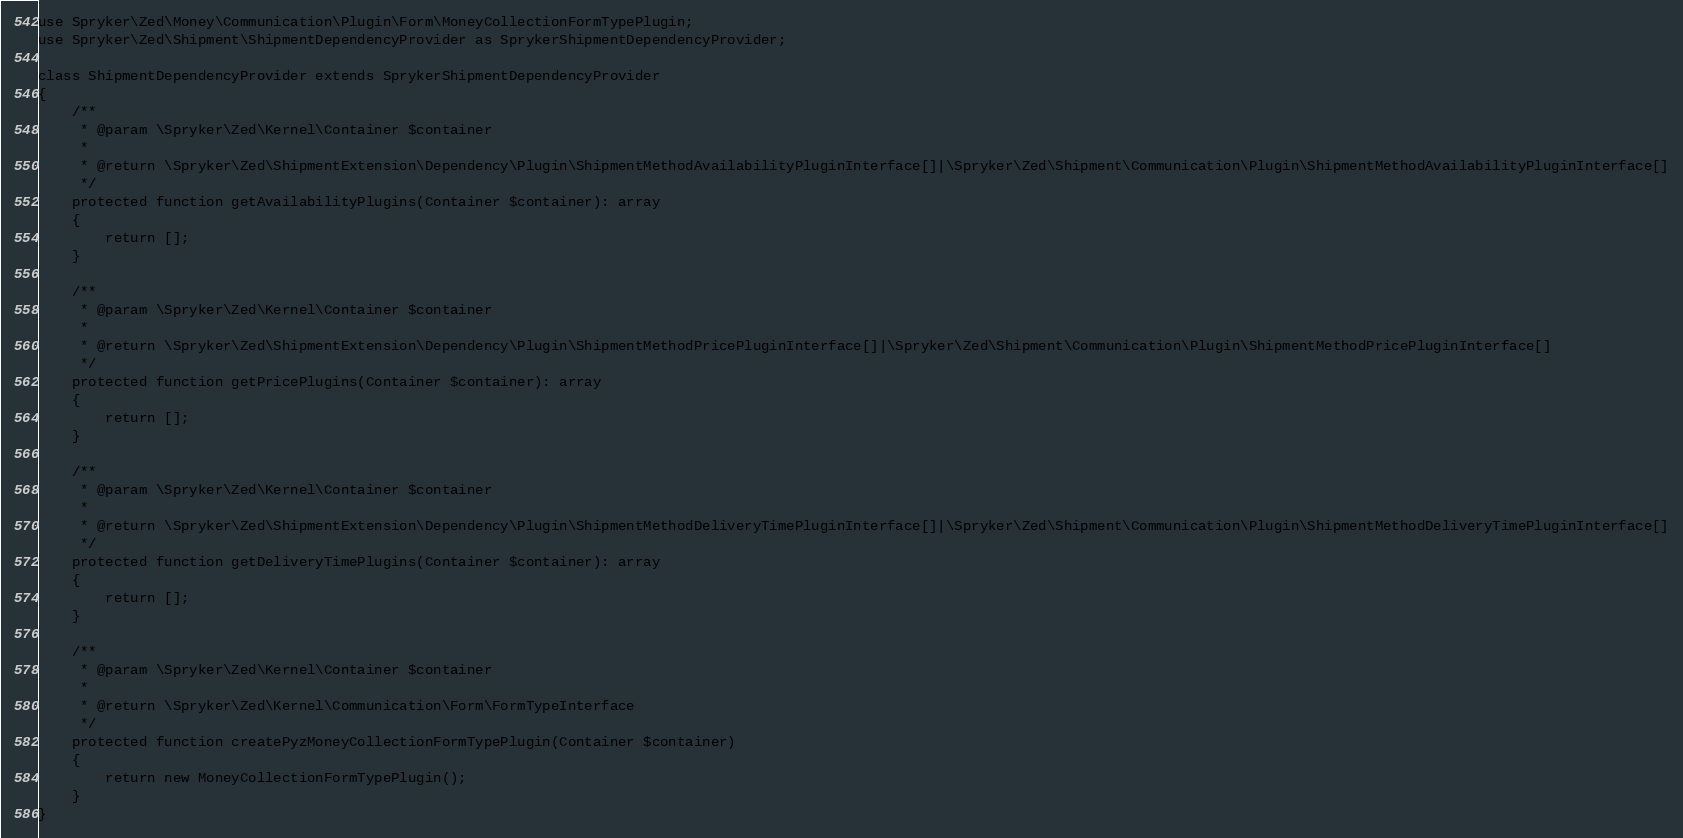Convert code to text. <code><loc_0><loc_0><loc_500><loc_500><_PHP_>use Spryker\Zed\Money\Communication\Plugin\Form\MoneyCollectionFormTypePlugin;
use Spryker\Zed\Shipment\ShipmentDependencyProvider as SprykerShipmentDependencyProvider;

class ShipmentDependencyProvider extends SprykerShipmentDependencyProvider
{
    /**
     * @param \Spryker\Zed\Kernel\Container $container
     *
     * @return \Spryker\Zed\ShipmentExtension\Dependency\Plugin\ShipmentMethodAvailabilityPluginInterface[]|\Spryker\Zed\Shipment\Communication\Plugin\ShipmentMethodAvailabilityPluginInterface[]
     */
    protected function getAvailabilityPlugins(Container $container): array
    {
        return [];
    }

    /**
     * @param \Spryker\Zed\Kernel\Container $container
     *
     * @return \Spryker\Zed\ShipmentExtension\Dependency\Plugin\ShipmentMethodPricePluginInterface[]|\Spryker\Zed\Shipment\Communication\Plugin\ShipmentMethodPricePluginInterface[]
     */
    protected function getPricePlugins(Container $container): array
    {
        return [];
    }

    /**
     * @param \Spryker\Zed\Kernel\Container $container
     *
     * @return \Spryker\Zed\ShipmentExtension\Dependency\Plugin\ShipmentMethodDeliveryTimePluginInterface[]|\Spryker\Zed\Shipment\Communication\Plugin\ShipmentMethodDeliveryTimePluginInterface[]
     */
    protected function getDeliveryTimePlugins(Container $container): array
    {
        return [];
    }

    /**
     * @param \Spryker\Zed\Kernel\Container $container
     *
     * @return \Spryker\Zed\Kernel\Communication\Form\FormTypeInterface
     */
    protected function createPyzMoneyCollectionFormTypePlugin(Container $container)
    {
        return new MoneyCollectionFormTypePlugin();
    }
}
</code> 